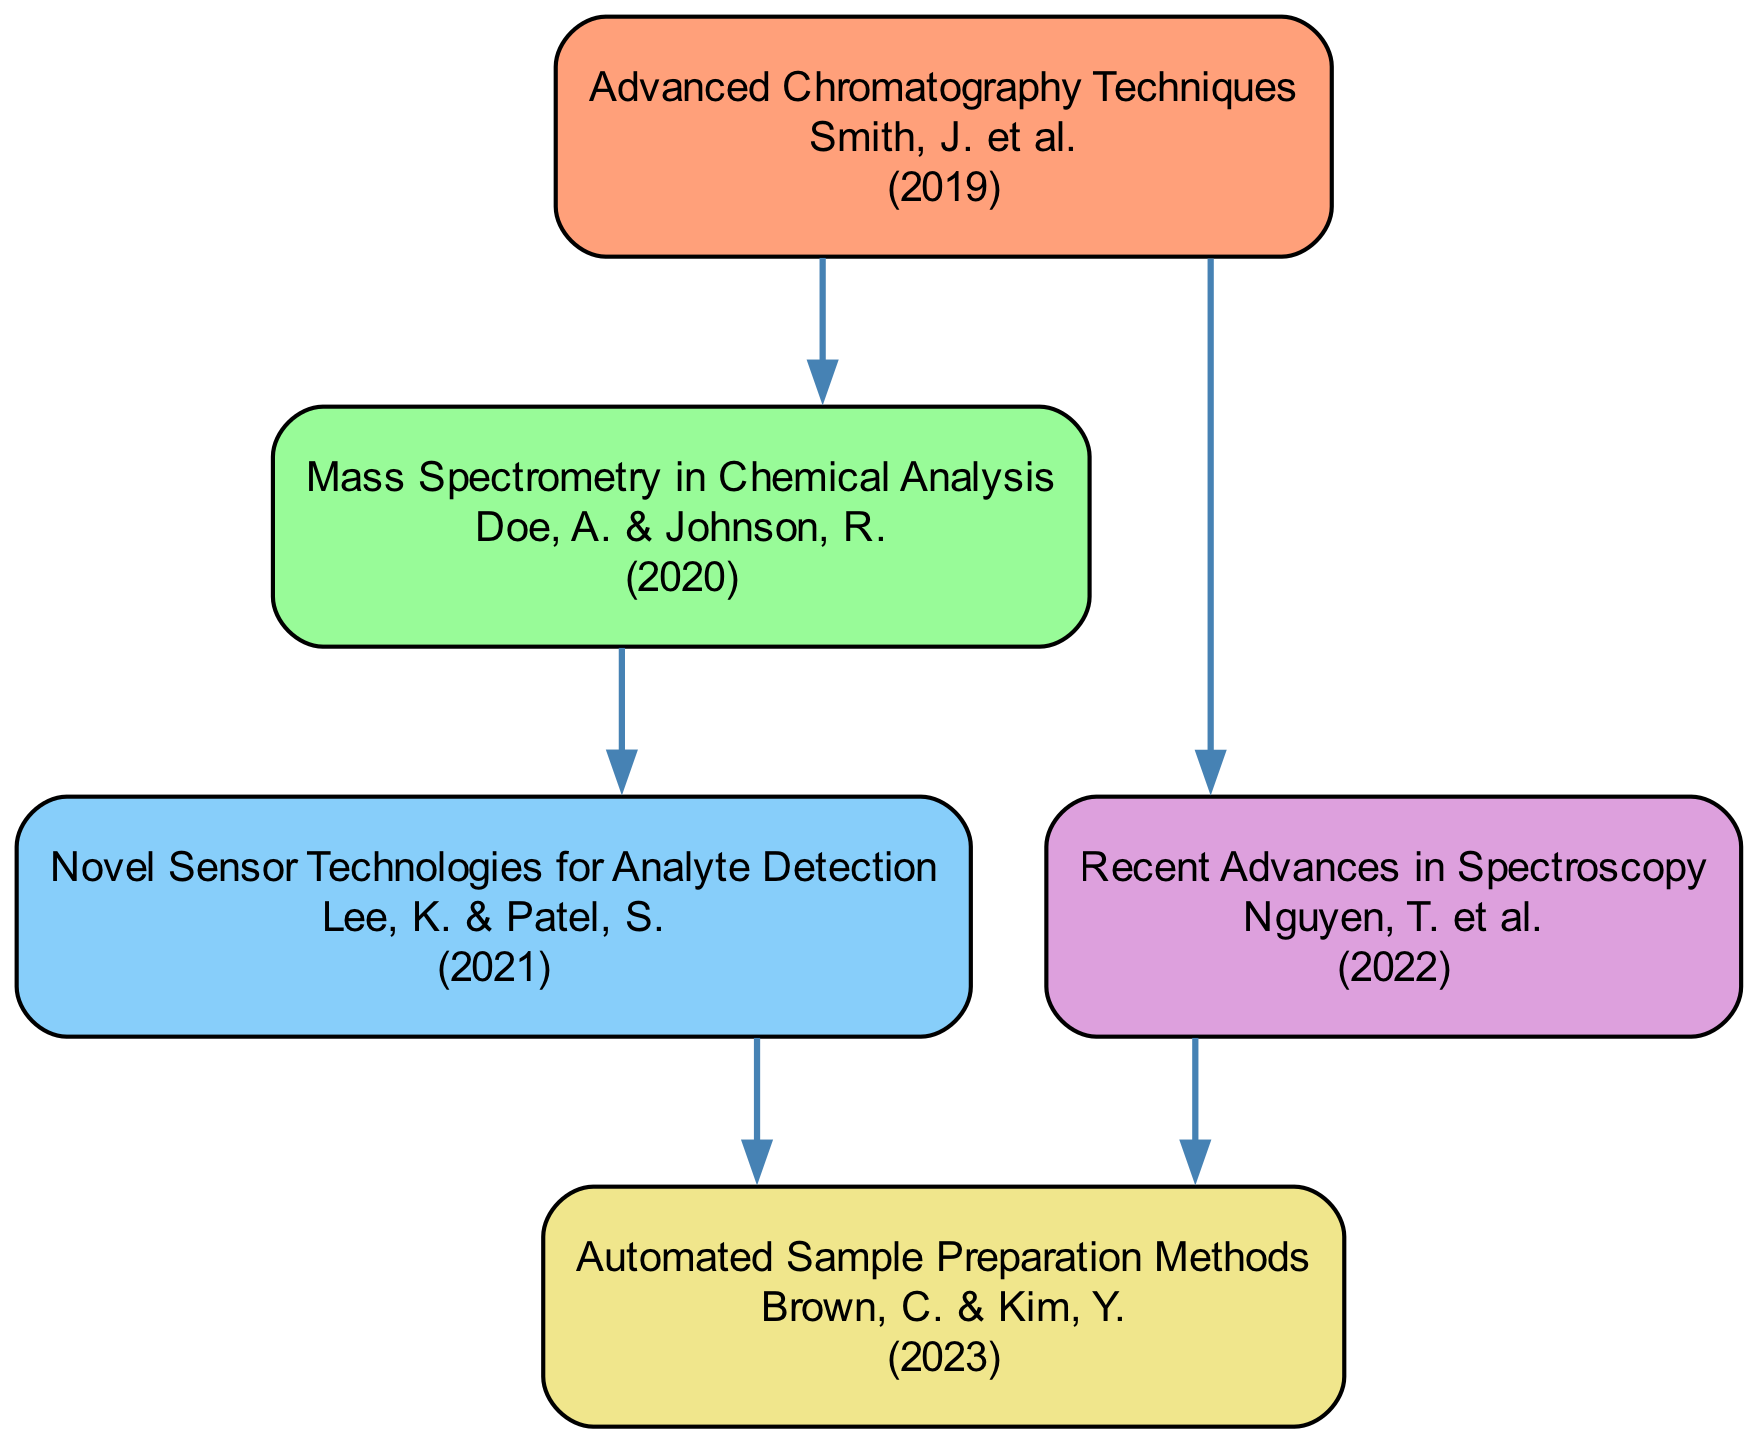What is the total number of nodes in the diagram? The total nodes are counted by listing each unique research paper in the diagram. There are five distinct papers indicated in the nodes section of the data.
Answer: 5 Which paper was cited by the paper "Advanced Chromatography Techniques"? To find this, we look for edges originating from the node with the title "Advanced Chromatography Techniques". This shows two citations leading to "Mass Spectrometry in Chemical Analysis" and "Recent Advances in Spectroscopy".
Answer: Mass Spectrometry in Chemical Analysis, Recent Advances in Spectroscopy How many edges are present in the diagram? Edges represent citations between papers. By referencing the edges section in the data, we count a total of five directed edges connecting the nodes.
Answer: 5 Which paper published in 2022 has edges pointing to it? We identify the paper published in 2022, which is "Recent Advances in Spectroscopy". By checking the edges, we see it has one edge leading to "Automated Sample Preparation Methods".
Answer: Automated Sample Preparation Methods What are the titles of papers that directly cite "Mass Spectrometry in Chemical Analysis"? This requires identifying which nodes point to "Mass Spectrometry in Chemical Analysis" by examining the edges. Upon checking, there is one paper that cites it: "Advanced Chromatography Techniques".
Answer: Advanced Chromatography Techniques Which author is associated with the most recent paper in this directed graph? The most recent paper is identified by the latest year in the nodes, which is 2023. The paper "Automated Sample Preparation Methods" corresponds to this date, and its authors are listed as "Brown, C. & Kim, Y.".
Answer: Brown, C. & Kim, Y Which two papers have a direct citation link to the most recent paper? To answer this, we first identify the most recent paper, which is "Automated Sample Preparation Methods", and then check the edges to see which papers cite it. Both "Recent Advances in Spectroscopy" and "Novel Sensor Technologies for Analyte Detection" have edges pointing to it.
Answer: Recent Advances in Spectroscopy, Novel Sensor Technologies for Analyte Detection How many unique authors are listed in this directed graph? To find this, we need to collect all authors from each node. The authors listed are Smith, J., Doe, A., Johnson, R., Lee, K., Patel, S., Nguyen, T., Brown, C., and Kim, Y.. After counting unique names, we find there are a total of eight unique authors.
Answer: 8 Which research paper has cited the most other papers based on the edges? This requires examining the number of outgoing edges from each node. "Advanced Chromatography Techniques" cites two papers, while the others cite either one or two, making it the one with the most extensive citations.
Answer: Advanced Chromatography Techniques 